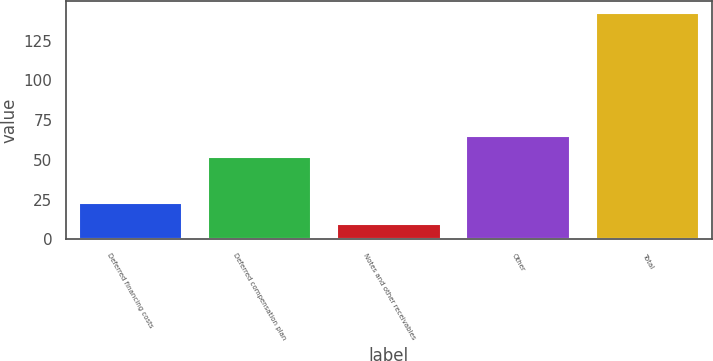Convert chart to OTSL. <chart><loc_0><loc_0><loc_500><loc_500><bar_chart><fcel>Deferred financing costs<fcel>Deferred compensation plan<fcel>Notes and other receivables<fcel>Other<fcel>Total<nl><fcel>22.8<fcel>51.5<fcel>9.5<fcel>65.2<fcel>142.5<nl></chart> 